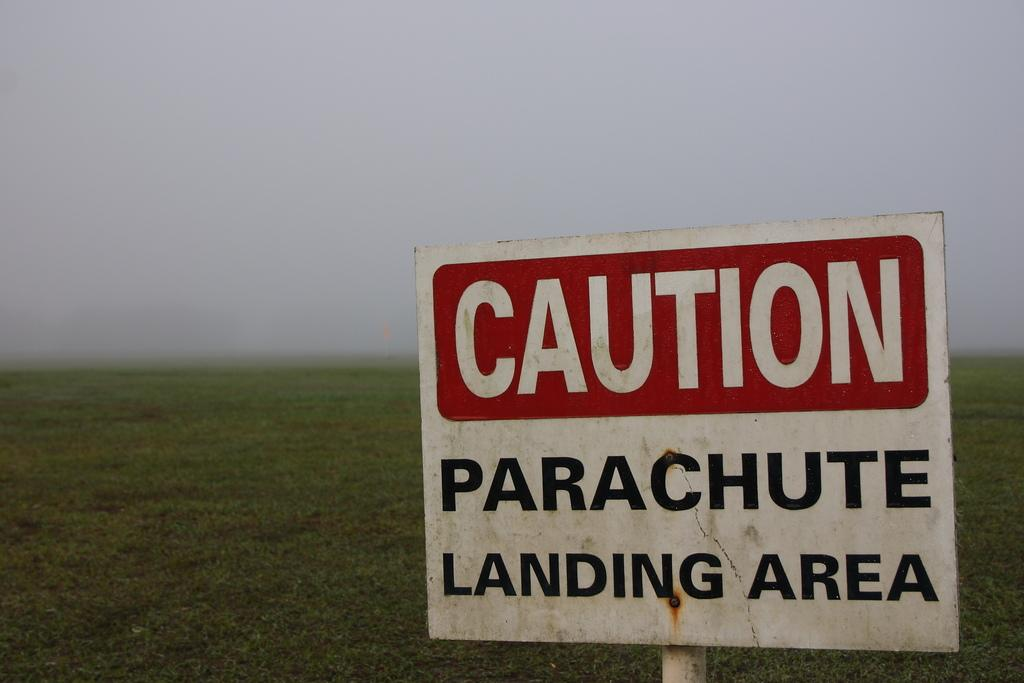<image>
Write a terse but informative summary of the picture. A sign sitting in the field with the words CAUTION Parachute landing area written on it. 